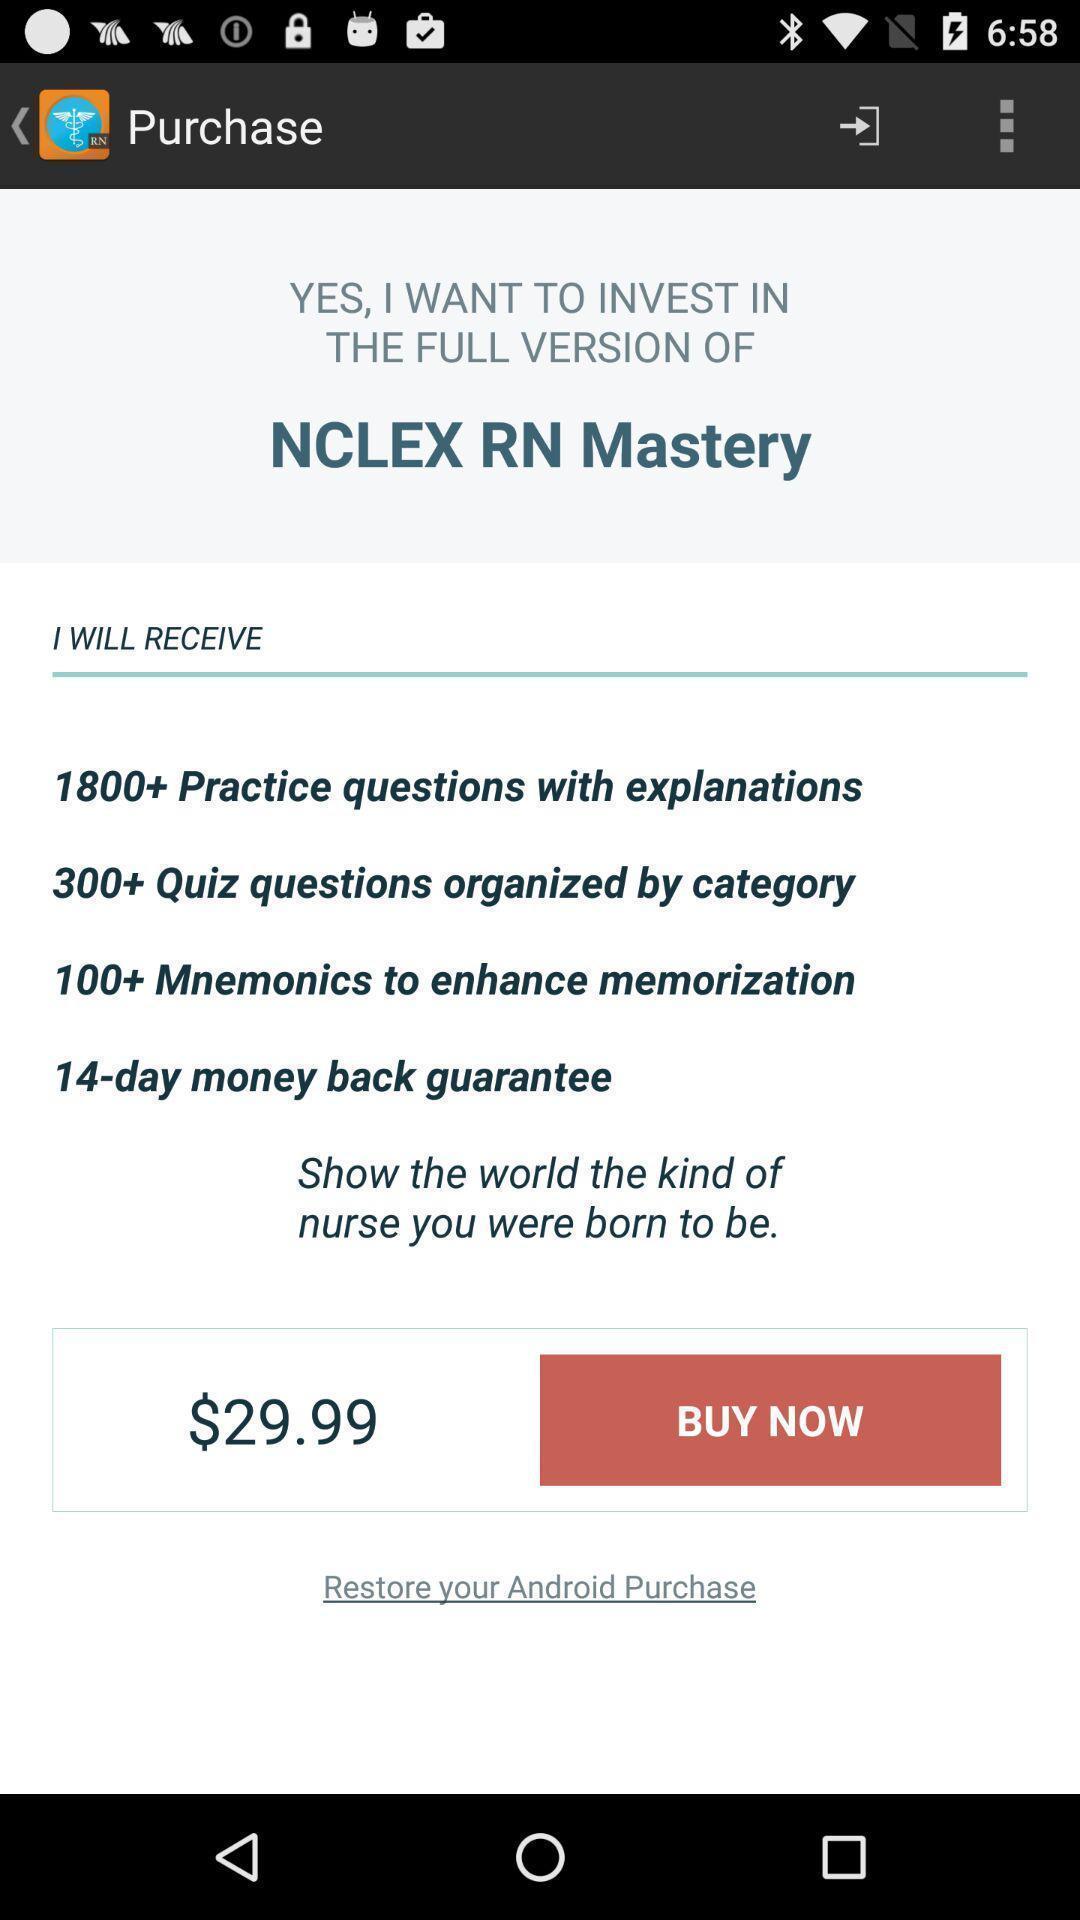Provide a description of this screenshot. Payment page. 